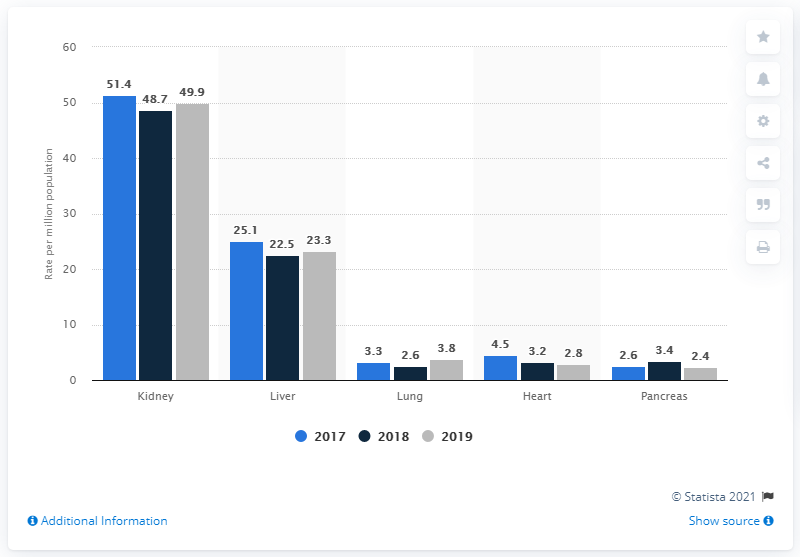Mention a couple of crucial points in this snapshot. The average for a pancreas transplant is 2.8. In 2017, the highest transplant was of the kidney. 